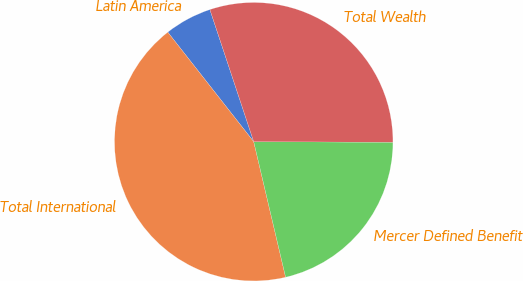<chart> <loc_0><loc_0><loc_500><loc_500><pie_chart><fcel>Latin America<fcel>Total International<fcel>Mercer Defined Benefit<fcel>Total Wealth<nl><fcel>5.49%<fcel>43.09%<fcel>21.26%<fcel>30.16%<nl></chart> 